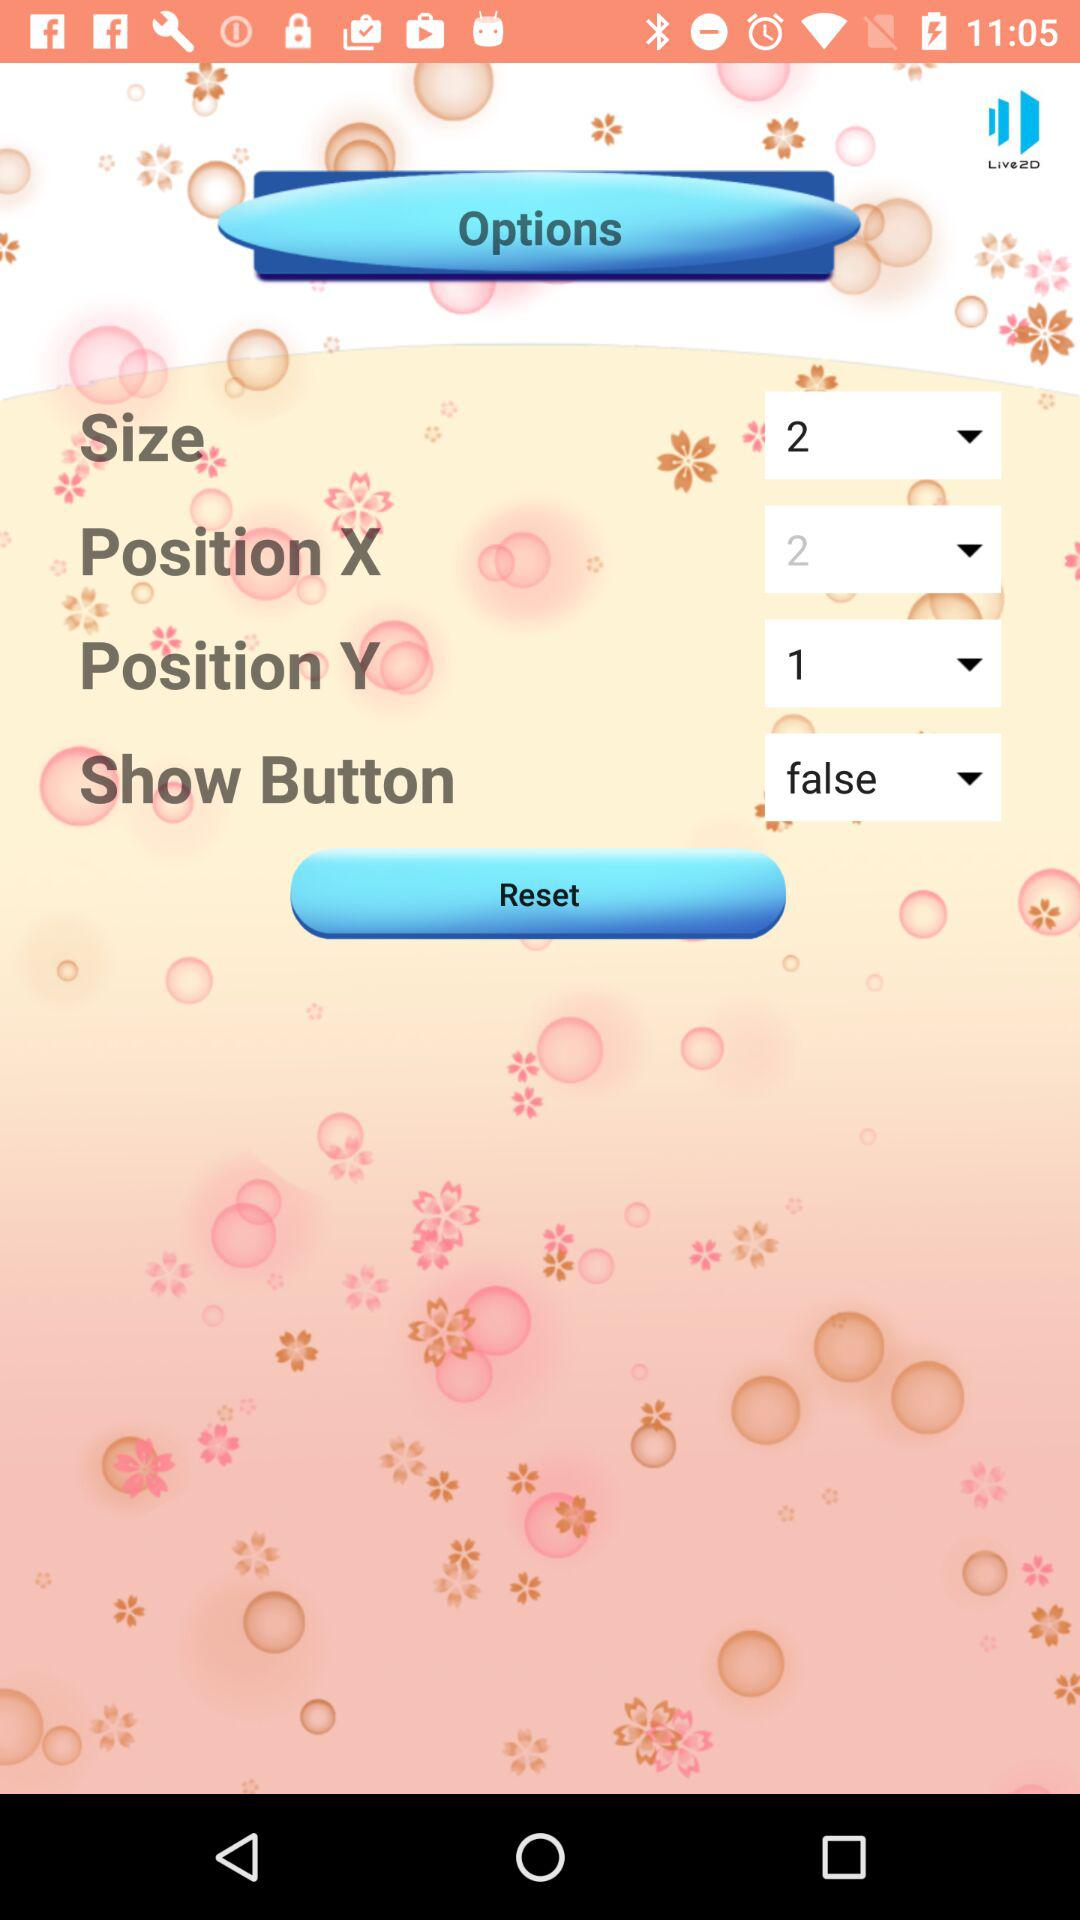Which number was selected for position X? The selected number was 2. 